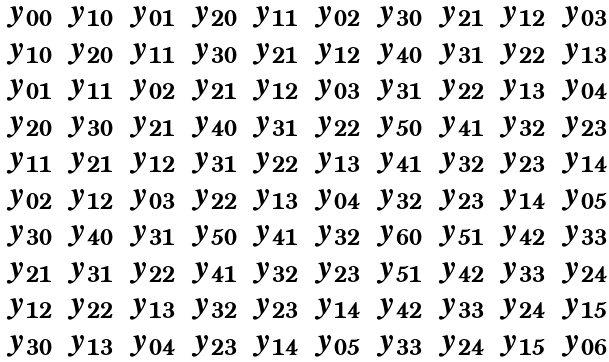Convert formula to latex. <formula><loc_0><loc_0><loc_500><loc_500>\begin{matrix} y _ { 0 0 } & y _ { 1 0 } & y _ { 0 1 } & y _ { 2 0 } & y _ { 1 1 } & y _ { 0 2 } & y _ { 3 0 } & y _ { 2 1 } & y _ { 1 2 } & y _ { 0 3 } \\ y _ { 1 0 } & y _ { 2 0 } & y _ { 1 1 } & y _ { 3 0 } & y _ { 2 1 } & y _ { 1 2 } & y _ { 4 0 } & y _ { 3 1 } & y _ { 2 2 } & y _ { 1 3 } \\ y _ { 0 1 } & y _ { 1 1 } & y _ { 0 2 } & y _ { 2 1 } & y _ { 1 2 } & y _ { 0 3 } & y _ { 3 1 } & y _ { 2 2 } & y _ { 1 3 } & y _ { 0 4 } \\ y _ { 2 0 } & y _ { 3 0 } & y _ { 2 1 } & y _ { 4 0 } & y _ { 3 1 } & y _ { 2 2 } & y _ { 5 0 } & y _ { 4 1 } & y _ { 3 2 } & y _ { 2 3 } \\ y _ { 1 1 } & y _ { 2 1 } & y _ { 1 2 } & y _ { 3 1 } & y _ { 2 2 } & y _ { 1 3 } & y _ { 4 1 } & y _ { 3 2 } & y _ { 2 3 } & y _ { 1 4 } \\ y _ { 0 2 } & y _ { 1 2 } & y _ { 0 3 } & y _ { 2 2 } & y _ { 1 3 } & y _ { 0 4 } & y _ { 3 2 } & y _ { 2 3 } & y _ { 1 4 } & y _ { 0 5 } \\ y _ { 3 0 } & y _ { 4 0 } & y _ { 3 1 } & y _ { 5 0 } & y _ { 4 1 } & y _ { 3 2 } & y _ { 6 0 } & y _ { 5 1 } & y _ { 4 2 } & y _ { 3 3 } \\ y _ { 2 1 } & y _ { 3 1 } & y _ { 2 2 } & y _ { 4 1 } & y _ { 3 2 } & y _ { 2 3 } & y _ { 5 1 } & y _ { 4 2 } & y _ { 3 3 } & y _ { 2 4 } \\ y _ { 1 2 } & y _ { 2 2 } & y _ { 1 3 } & y _ { 3 2 } & y _ { 2 3 } & y _ { 1 4 } & y _ { 4 2 } & y _ { 3 3 } & y _ { 2 4 } & y _ { 1 5 } \\ y _ { 3 0 } & y _ { 1 3 } & y _ { 0 4 } & y _ { 2 3 } & y _ { 1 4 } & y _ { 0 5 } & y _ { 3 3 } & y _ { 2 4 } & y _ { 1 5 } & y _ { 0 6 } \\ \end{matrix}</formula> 